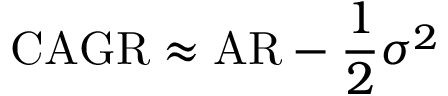<formula> <loc_0><loc_0><loc_500><loc_500>C A G R \approx A R - { \frac { 1 } { 2 } } \sigma ^ { 2 }</formula> 